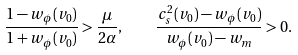<formula> <loc_0><loc_0><loc_500><loc_500>\frac { 1 - w _ { \phi } ( v _ { 0 } ) } { 1 + w _ { \phi } ( v _ { 0 } ) } > \frac { \mu } { 2 \alpha } , \quad \frac { c _ { s } ^ { 2 } ( v _ { 0 } ) - w _ { \phi } ( v _ { 0 } ) } { w _ { \phi } ( v _ { 0 } ) - w _ { m } } > 0 .</formula> 